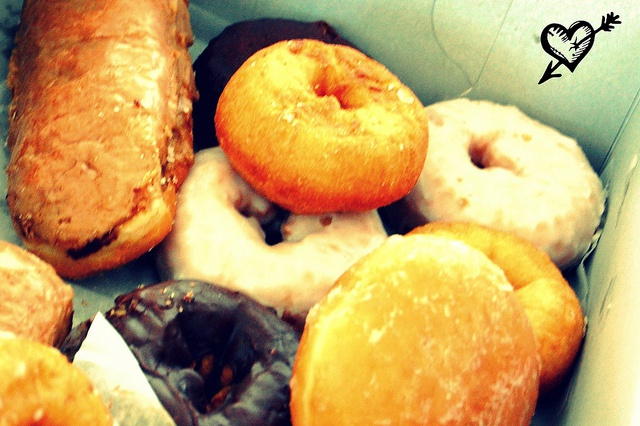Describe the objects in this image and their specific colors. I can see donut in teal, gold, orange, and khaki tones, donut in teal, gold, orange, and red tones, donut in teal, lightyellow, khaki, and tan tones, donut in teal, khaki, lightyellow, and tan tones, and donut in teal, black, gray, and maroon tones in this image. 